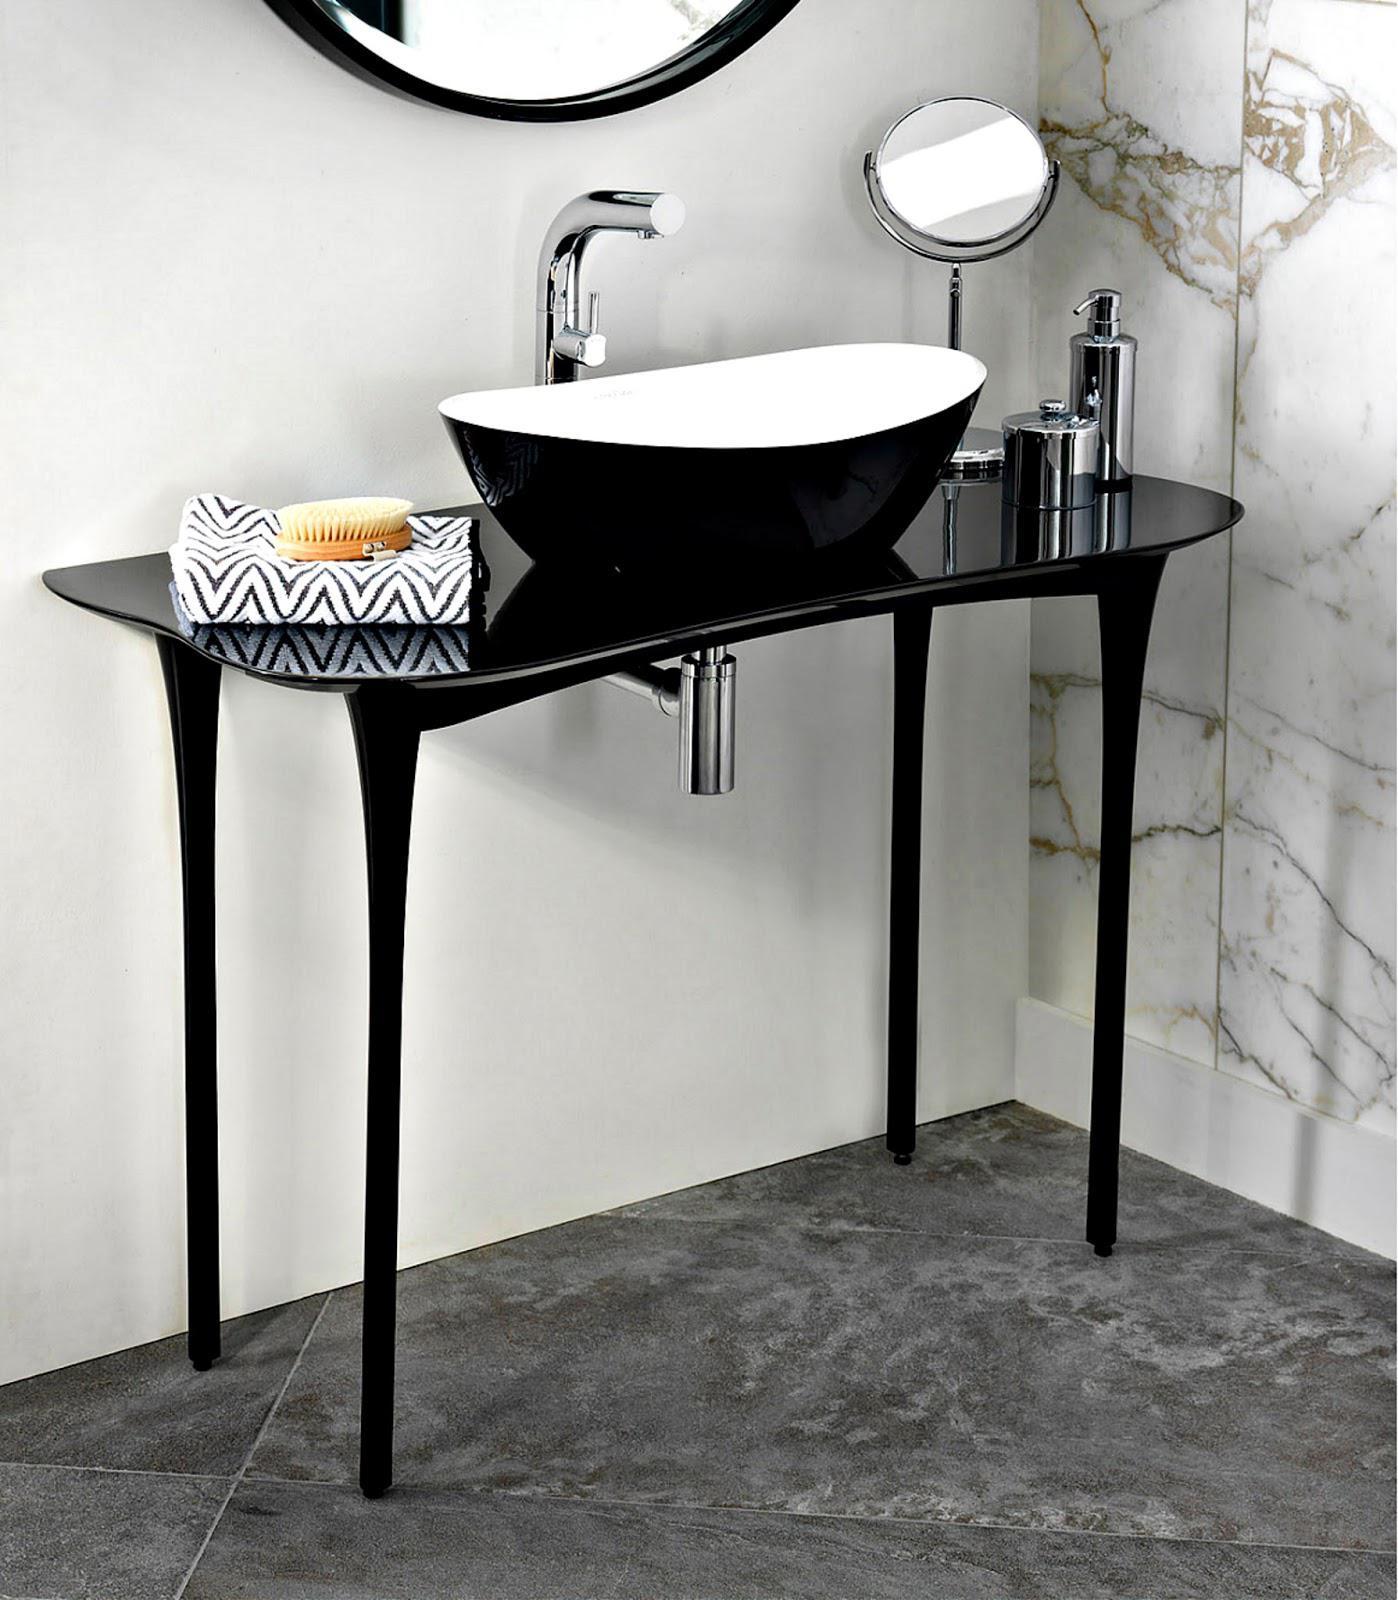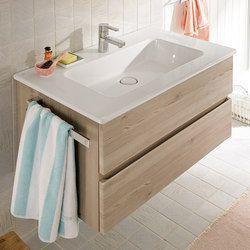The first image is the image on the left, the second image is the image on the right. Examine the images to the left and right. Is the description "In one image, a white vanity with white sink area has two chrome spout faucets and towels hanging on racks at each end of the vanity." accurate? Answer yes or no. No. The first image is the image on the left, the second image is the image on the right. Given the left and right images, does the statement "The right image shows a top-view of a rectangular single-basin sink with a wall-mounted vanity that has a chrome towel bar on the side." hold true? Answer yes or no. Yes. 